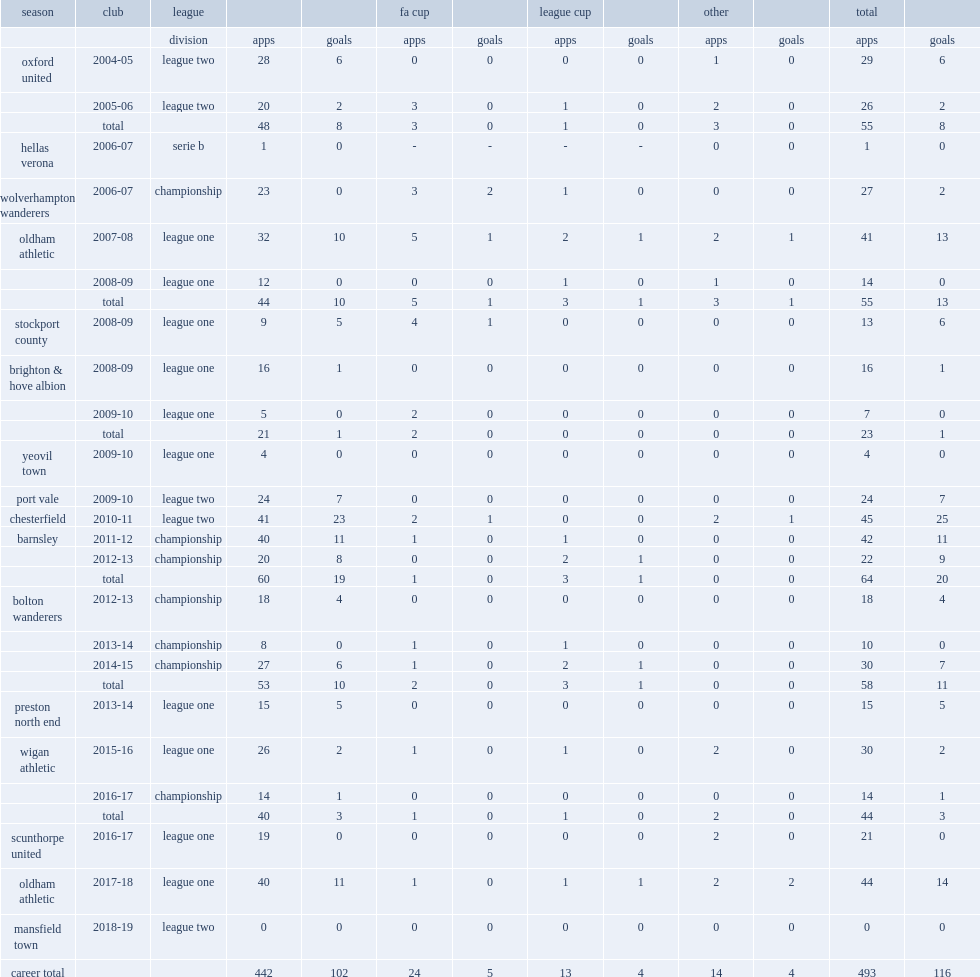Which club did davies join in league one club for the 2016-17 season? Scunthorpe united. 